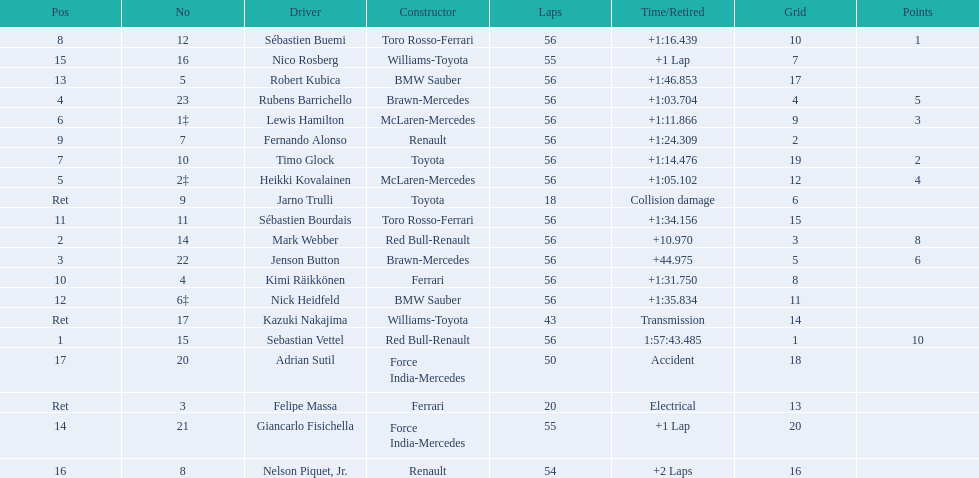Which drive retired because of electrical issues? Felipe Massa. Which driver retired due to accident? Adrian Sutil. Which driver retired due to collision damage? Jarno Trulli. 